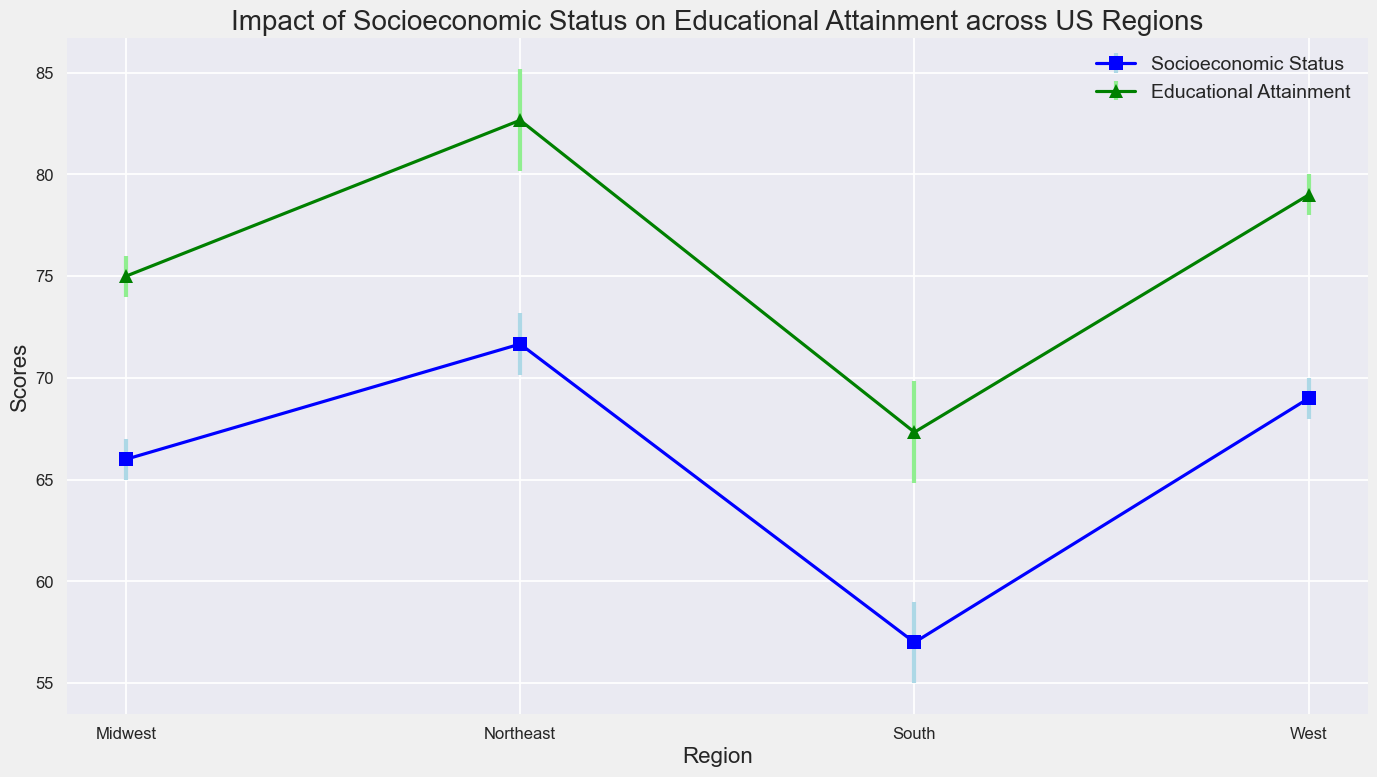What's the average mean educational attainment in the Northeast region? The chart shows three mean educational attainment values for the Northeast: 80, 83, and 85. Summing these gives 80 + 83 + 85 = 248, and dividing by 3, the average is 248/3 ≈ 82.67.
Answer: 82.67 How does the mean educational attainment in the West compare to the South? The chart shows that the West has mean educational attainment values of 78, 80, and 79 with an average ( (78 + 80 + 79) / 3 = 79), while the South has values of 65, 67, and 70 with an average ( (65 + 67 + 70) / 3 ≈ 67.33). Therefore, the West has a higher mean educational attainment.
Answer: West has higher educational attainment Which region has the highest mean socioeconomic status? By comparing the mean socioeconomic status in each region based on the plot: Northeast (average 71.67), Midwest (average 66), South (average 57), and West (average 69). The Northeast has the highest mean socioeconomic status.
Answer: Northeast What is the difference in mean educational attainment between the Northeast and Midwest? The average mean educational attainment for the Northeast is 82.67, and for the Midwest is (75 + 76 + 74) / 3 ≈ 75. Therefore, the difference is 82.67 - 75 ≈ 7.67.
Answer: 7.67 Which region has the largest standard deviation in socioeconomic status? The chart shows standard deviations in socioeconomic status: Northeast (from 5, 4, 3, average = 4), Midwest (7, 8, 6, average = 7), South (10, 9, 11, average = 10), West (6, 5, 7, average = 6). The South has the largest standard deviation.
Answer: South Are the error bars for socioeconomic status larger or smaller than those for educational attainment in the West region? The error bars for socioeconomic status in the West are given by standard deviations 6, 5, and 7 (average = 6), whereas for educational attainment, they are 8, 7, and 6 (average = 7). The error bars are smaller for socioeconomic status.
Answer: Error bars for socioeconomic status are smaller Is there a consistent trend in the relationship between socioeconomic status and educational attainment across all regions? Observing the plot for all regions, higher socioeconomic status correlates with higher mean educational attainment in the Northeast, Midwest, South, and West. This indicates a consistent positive trend across all regions.
Answer: Yes Can you identify any region where the standard deviation for educational attainment is lower than for socioeconomic status? Comparing the average standard deviations, Northeast's educational attainment (9) is lower than socioeconomic status (4), Midwest's educational attainment (10) is higher than socioeconomic status (7), South's educational attainment (14) is higher than socioeconomic status (10), and West's educational attainment (7) is higher than socioeconomic status (6). Thus, only the Northeast meets the criteria.
Answer: Northeast 